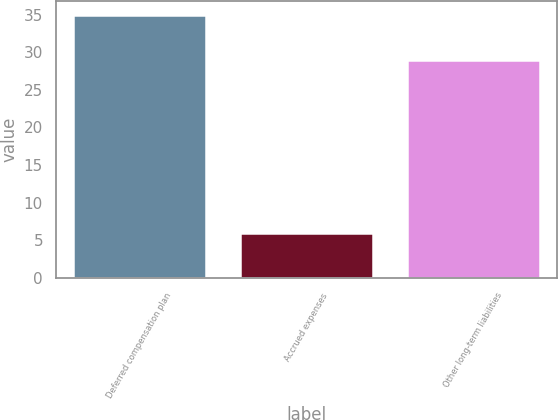Convert chart. <chart><loc_0><loc_0><loc_500><loc_500><bar_chart><fcel>Deferred compensation plan<fcel>Accrued expenses<fcel>Other long-term liabilities<nl><fcel>35<fcel>6<fcel>29<nl></chart> 